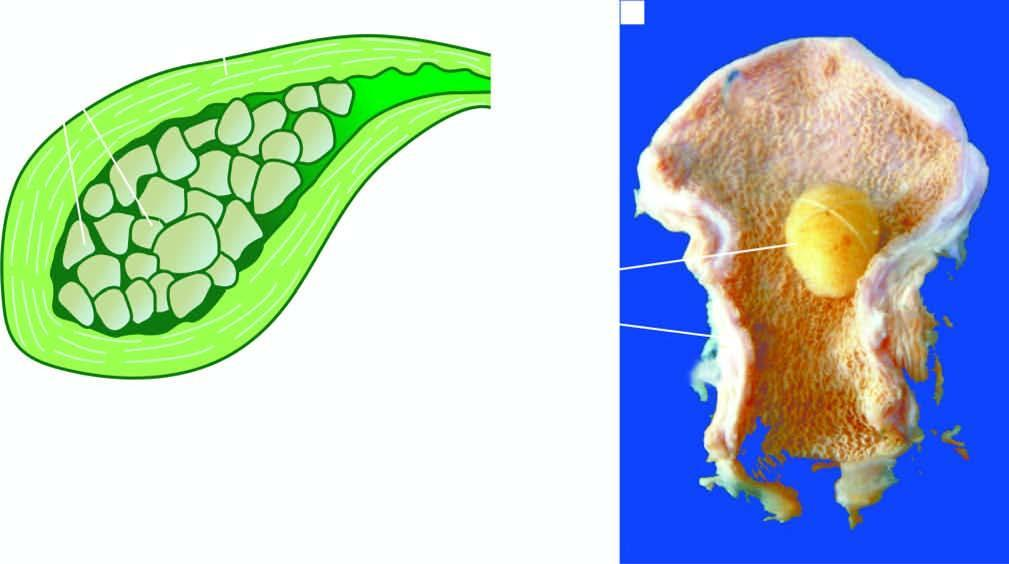s the intervening stroma thickened?
Answer the question using a single word or phrase. No 